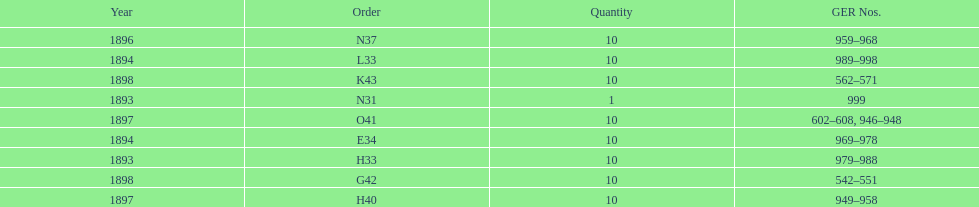What is the order of the last year listed? K43. 